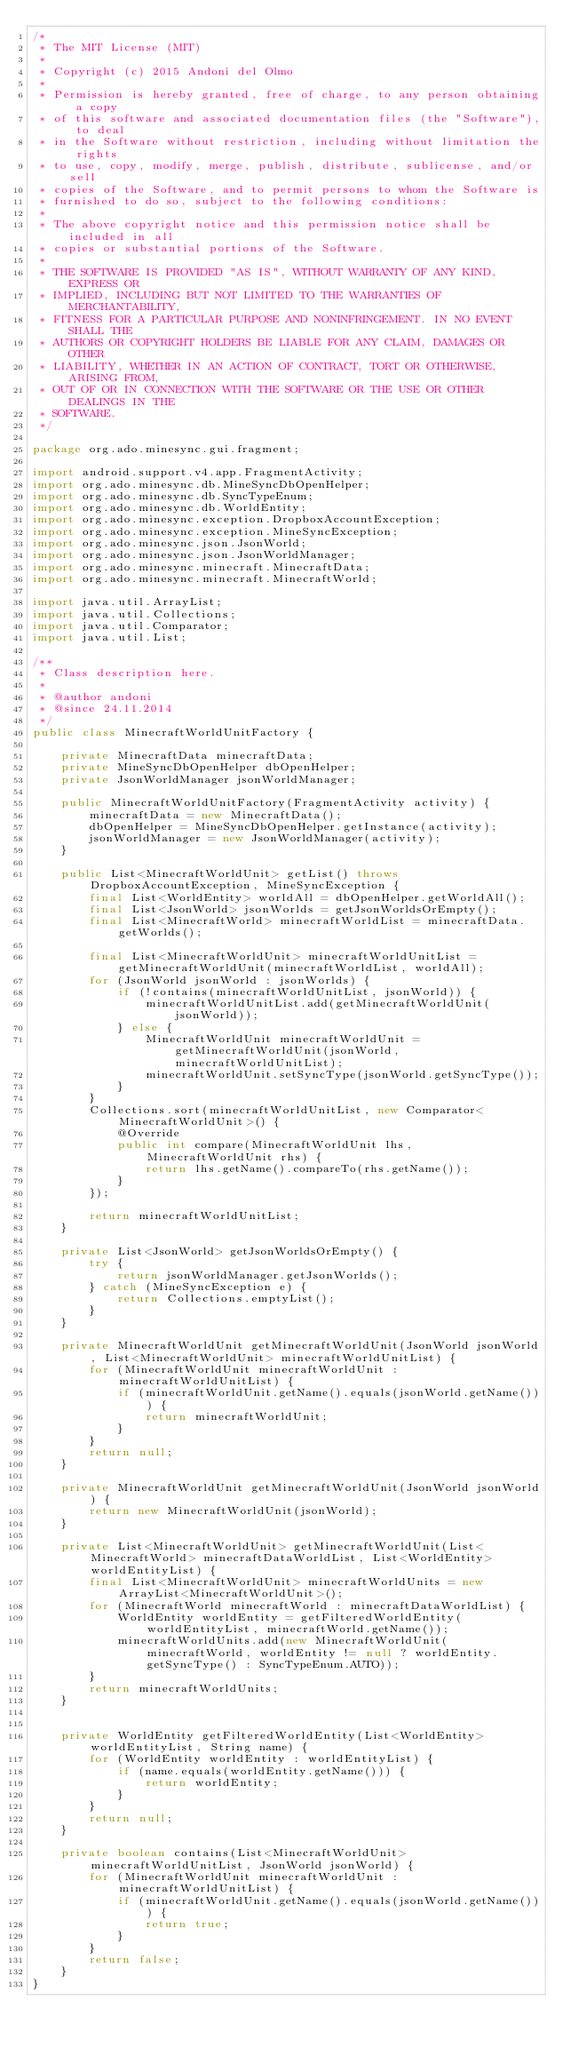Convert code to text. <code><loc_0><loc_0><loc_500><loc_500><_Java_>/*
 * The MIT License (MIT)
 *
 * Copyright (c) 2015 Andoni del Olmo
 *
 * Permission is hereby granted, free of charge, to any person obtaining a copy
 * of this software and associated documentation files (the "Software"), to deal
 * in the Software without restriction, including without limitation the rights
 * to use, copy, modify, merge, publish, distribute, sublicense, and/or sell
 * copies of the Software, and to permit persons to whom the Software is
 * furnished to do so, subject to the following conditions:
 *
 * The above copyright notice and this permission notice shall be included in all
 * copies or substantial portions of the Software.
 *
 * THE SOFTWARE IS PROVIDED "AS IS", WITHOUT WARRANTY OF ANY KIND, EXPRESS OR
 * IMPLIED, INCLUDING BUT NOT LIMITED TO THE WARRANTIES OF MERCHANTABILITY,
 * FITNESS FOR A PARTICULAR PURPOSE AND NONINFRINGEMENT. IN NO EVENT SHALL THE
 * AUTHORS OR COPYRIGHT HOLDERS BE LIABLE FOR ANY CLAIM, DAMAGES OR OTHER
 * LIABILITY, WHETHER IN AN ACTION OF CONTRACT, TORT OR OTHERWISE, ARISING FROM,
 * OUT OF OR IN CONNECTION WITH THE SOFTWARE OR THE USE OR OTHER DEALINGS IN THE
 * SOFTWARE.
 */

package org.ado.minesync.gui.fragment;

import android.support.v4.app.FragmentActivity;
import org.ado.minesync.db.MineSyncDbOpenHelper;
import org.ado.minesync.db.SyncTypeEnum;
import org.ado.minesync.db.WorldEntity;
import org.ado.minesync.exception.DropboxAccountException;
import org.ado.minesync.exception.MineSyncException;
import org.ado.minesync.json.JsonWorld;
import org.ado.minesync.json.JsonWorldManager;
import org.ado.minesync.minecraft.MinecraftData;
import org.ado.minesync.minecraft.MinecraftWorld;

import java.util.ArrayList;
import java.util.Collections;
import java.util.Comparator;
import java.util.List;

/**
 * Class description here.
 *
 * @author andoni
 * @since 24.11.2014
 */
public class MinecraftWorldUnitFactory {

    private MinecraftData minecraftData;
    private MineSyncDbOpenHelper dbOpenHelper;
    private JsonWorldManager jsonWorldManager;

    public MinecraftWorldUnitFactory(FragmentActivity activity) {
        minecraftData = new MinecraftData();
        dbOpenHelper = MineSyncDbOpenHelper.getInstance(activity);
        jsonWorldManager = new JsonWorldManager(activity);
    }

    public List<MinecraftWorldUnit> getList() throws DropboxAccountException, MineSyncException {
        final List<WorldEntity> worldAll = dbOpenHelper.getWorldAll();
        final List<JsonWorld> jsonWorlds = getJsonWorldsOrEmpty();
        final List<MinecraftWorld> minecraftWorldList = minecraftData.getWorlds();

        final List<MinecraftWorldUnit> minecraftWorldUnitList = getMinecraftWorldUnit(minecraftWorldList, worldAll);
        for (JsonWorld jsonWorld : jsonWorlds) {
            if (!contains(minecraftWorldUnitList, jsonWorld)) {
                minecraftWorldUnitList.add(getMinecraftWorldUnit(jsonWorld));
            } else {
                MinecraftWorldUnit minecraftWorldUnit = getMinecraftWorldUnit(jsonWorld, minecraftWorldUnitList);
                minecraftWorldUnit.setSyncType(jsonWorld.getSyncType());
            }
        }
        Collections.sort(minecraftWorldUnitList, new Comparator<MinecraftWorldUnit>() {
            @Override
            public int compare(MinecraftWorldUnit lhs, MinecraftWorldUnit rhs) {
                return lhs.getName().compareTo(rhs.getName());
            }
        });

        return minecraftWorldUnitList;
    }

    private List<JsonWorld> getJsonWorldsOrEmpty() {
        try {
            return jsonWorldManager.getJsonWorlds();
        } catch (MineSyncException e) {
            return Collections.emptyList();
        }
    }

    private MinecraftWorldUnit getMinecraftWorldUnit(JsonWorld jsonWorld, List<MinecraftWorldUnit> minecraftWorldUnitList) {
        for (MinecraftWorldUnit minecraftWorldUnit : minecraftWorldUnitList) {
            if (minecraftWorldUnit.getName().equals(jsonWorld.getName())) {
                return minecraftWorldUnit;
            }
        }
        return null;
    }

    private MinecraftWorldUnit getMinecraftWorldUnit(JsonWorld jsonWorld) {
        return new MinecraftWorldUnit(jsonWorld);
    }

    private List<MinecraftWorldUnit> getMinecraftWorldUnit(List<MinecraftWorld> minecraftDataWorldList, List<WorldEntity> worldEntityList) {
        final List<MinecraftWorldUnit> minecraftWorldUnits = new ArrayList<MinecraftWorldUnit>();
        for (MinecraftWorld minecraftWorld : minecraftDataWorldList) {
            WorldEntity worldEntity = getFilteredWorldEntity(worldEntityList, minecraftWorld.getName());
            minecraftWorldUnits.add(new MinecraftWorldUnit(minecraftWorld, worldEntity != null ? worldEntity.getSyncType() : SyncTypeEnum.AUTO));
        }
        return minecraftWorldUnits;
    }


    private WorldEntity getFilteredWorldEntity(List<WorldEntity> worldEntityList, String name) {
        for (WorldEntity worldEntity : worldEntityList) {
            if (name.equals(worldEntity.getName())) {
                return worldEntity;
            }
        }
        return null;
    }

    private boolean contains(List<MinecraftWorldUnit> minecraftWorldUnitList, JsonWorld jsonWorld) {
        for (MinecraftWorldUnit minecraftWorldUnit : minecraftWorldUnitList) {
            if (minecraftWorldUnit.getName().equals(jsonWorld.getName())) {
                return true;
            }
        }
        return false;
    }
}
</code> 